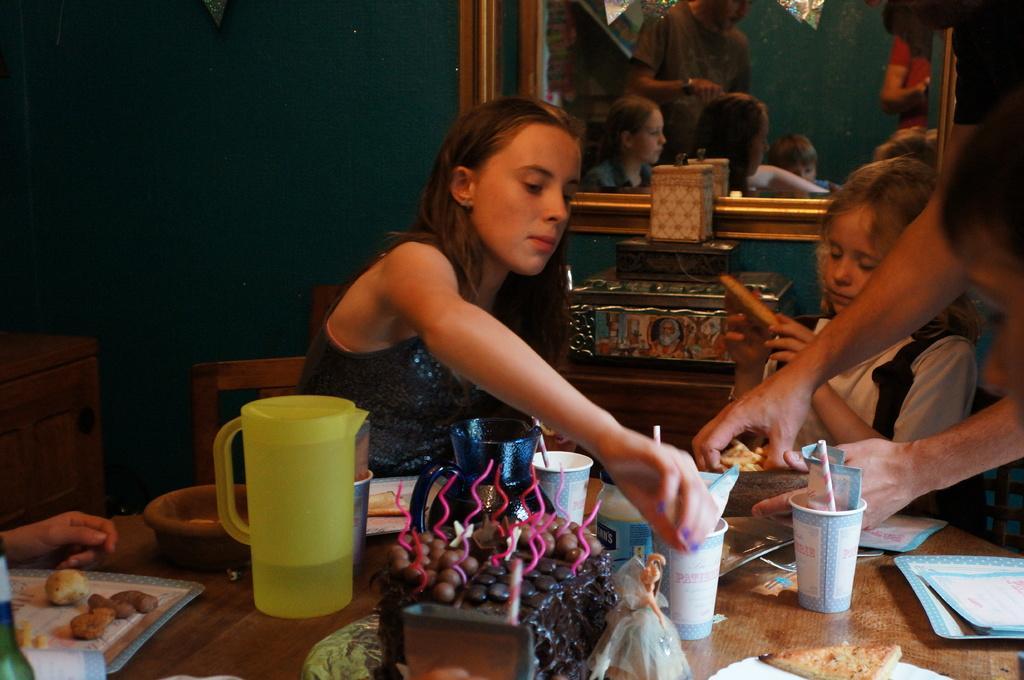How would you summarize this image in a sentence or two? In this image I see few people who are in front of a table and there are lot of things on the table. In the background I see the wall and the mirror. 